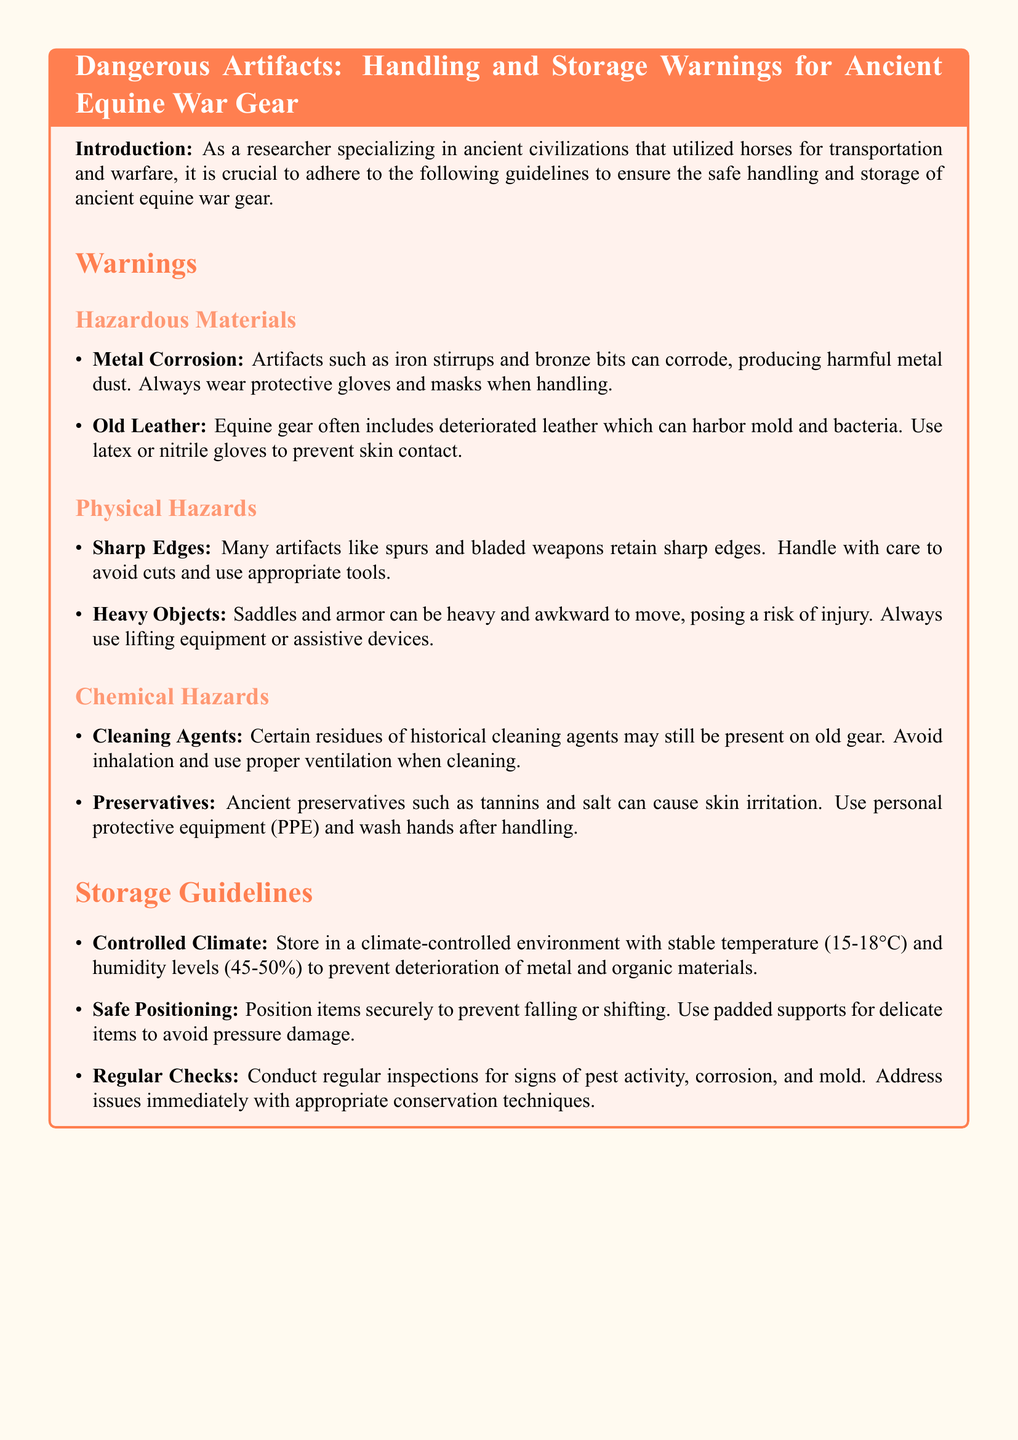What types of hazardous materials can be found in ancient equine war gear? The document lists that the hazardous materials include metal corrosion and old leather.
Answer: metal corrosion, old leather What is the recommended temperature range for storing these artifacts? The document specifies a stable temperature range of 15-18°C for storage.
Answer: 15-18°C What personal protective equipment is suggested for handling old leather? The document indicates using latex or nitrile gloves when handling old leather.
Answer: latex or nitrile gloves What is the primary risk associated with sharp edges on equine war gear? The primary risk mentioned in the document is cuts from the sharp edges of artifacts.
Answer: cuts How often should inspections for pest activity be conducted? The document does not specify a frequency but emphasizes conducting regular inspections.
Answer: regular inspections 